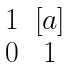<formula> <loc_0><loc_0><loc_500><loc_500>\begin{matrix} 1 & [ a ] \\ 0 & 1 \end{matrix}</formula> 